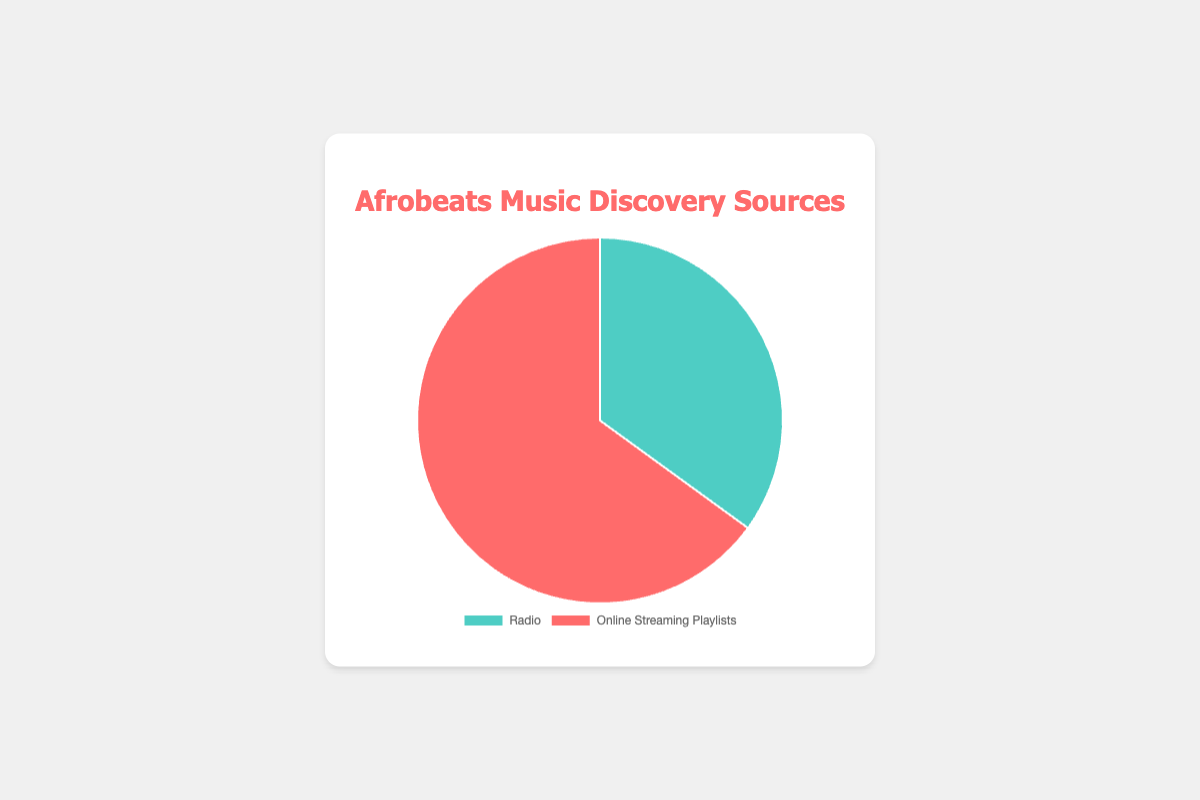Which source has the highest percentage of Afrobeats music discovery? The pie chart shows two sources, Radio and Online Streaming Playlists, with associated percentages. By looking at the chart, the Online Streaming Playlists section occupies a larger area.
Answer: Online Streaming Playlists What's the total of Radio and Online Streaming Playlists percentages? Sum the percentages for Radio and Online Streaming Playlists. 35% (Radio) + 65% (Online Streaming Playlists).
Answer: 100% What is the difference in percentage between Radio and Online Streaming Playlists? Subtract the percentage of Radio from the percentage of Online Streaming Playlists. 65% (Online Streaming Playlists) - 35% (Radio).
Answer: 30% Which color represents Online Streaming Playlists in the pie chart? The pie chart has different colors for each section. Online Streaming Playlists is colored in red.
Answer: Red If you were to combine Radio and Online Streaming Playlists into one category, what would be the average percentage? The sum of both percentages is 100%. The average is the sum divided by the number of categories (2). 100% / 2.
Answer: 50% Which source has a lower percentage of Afrobeats music discovery? The pie chart shows two percentages: 35% for Radio and 65% for Online Streaming Playlists. The smaller value is for Radio.
Answer: Radio What percentage of people discover Afrobeats music via Radio according to the chart? The chart directly indicates that 35% of people discover Afrobeats music through Radio.
Answer: 35% Is the percentage of Online Streaming Playlists greater than twice the percentage of Radio? Calculate twice the percentage of Radio: 35% * 2 = 70%. The percentage for Online Streaming Playlists is 65%. Since 65% is not greater than 70%, the answer is no.
Answer: No What percentage of people discover Afrobeats music through Online Streaming Playlists according to the chart? The chart directly indicates that 65% of people discover Afrobeats music through Online Streaming Playlists.
Answer: 65% 